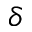Convert formula to latex. <formula><loc_0><loc_0><loc_500><loc_500>\delta</formula> 